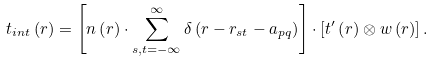<formula> <loc_0><loc_0><loc_500><loc_500>t _ { i n t } \left ( r \right ) = \left [ n \left ( r \right ) \cdot \sum _ { s , t = - \infty } ^ { \infty } \delta \left ( r - r _ { s t } - a _ { p q } \right ) \right ] \cdot \left [ t ^ { \prime } \left ( r \right ) \otimes w \left ( r \right ) \right ] .</formula> 